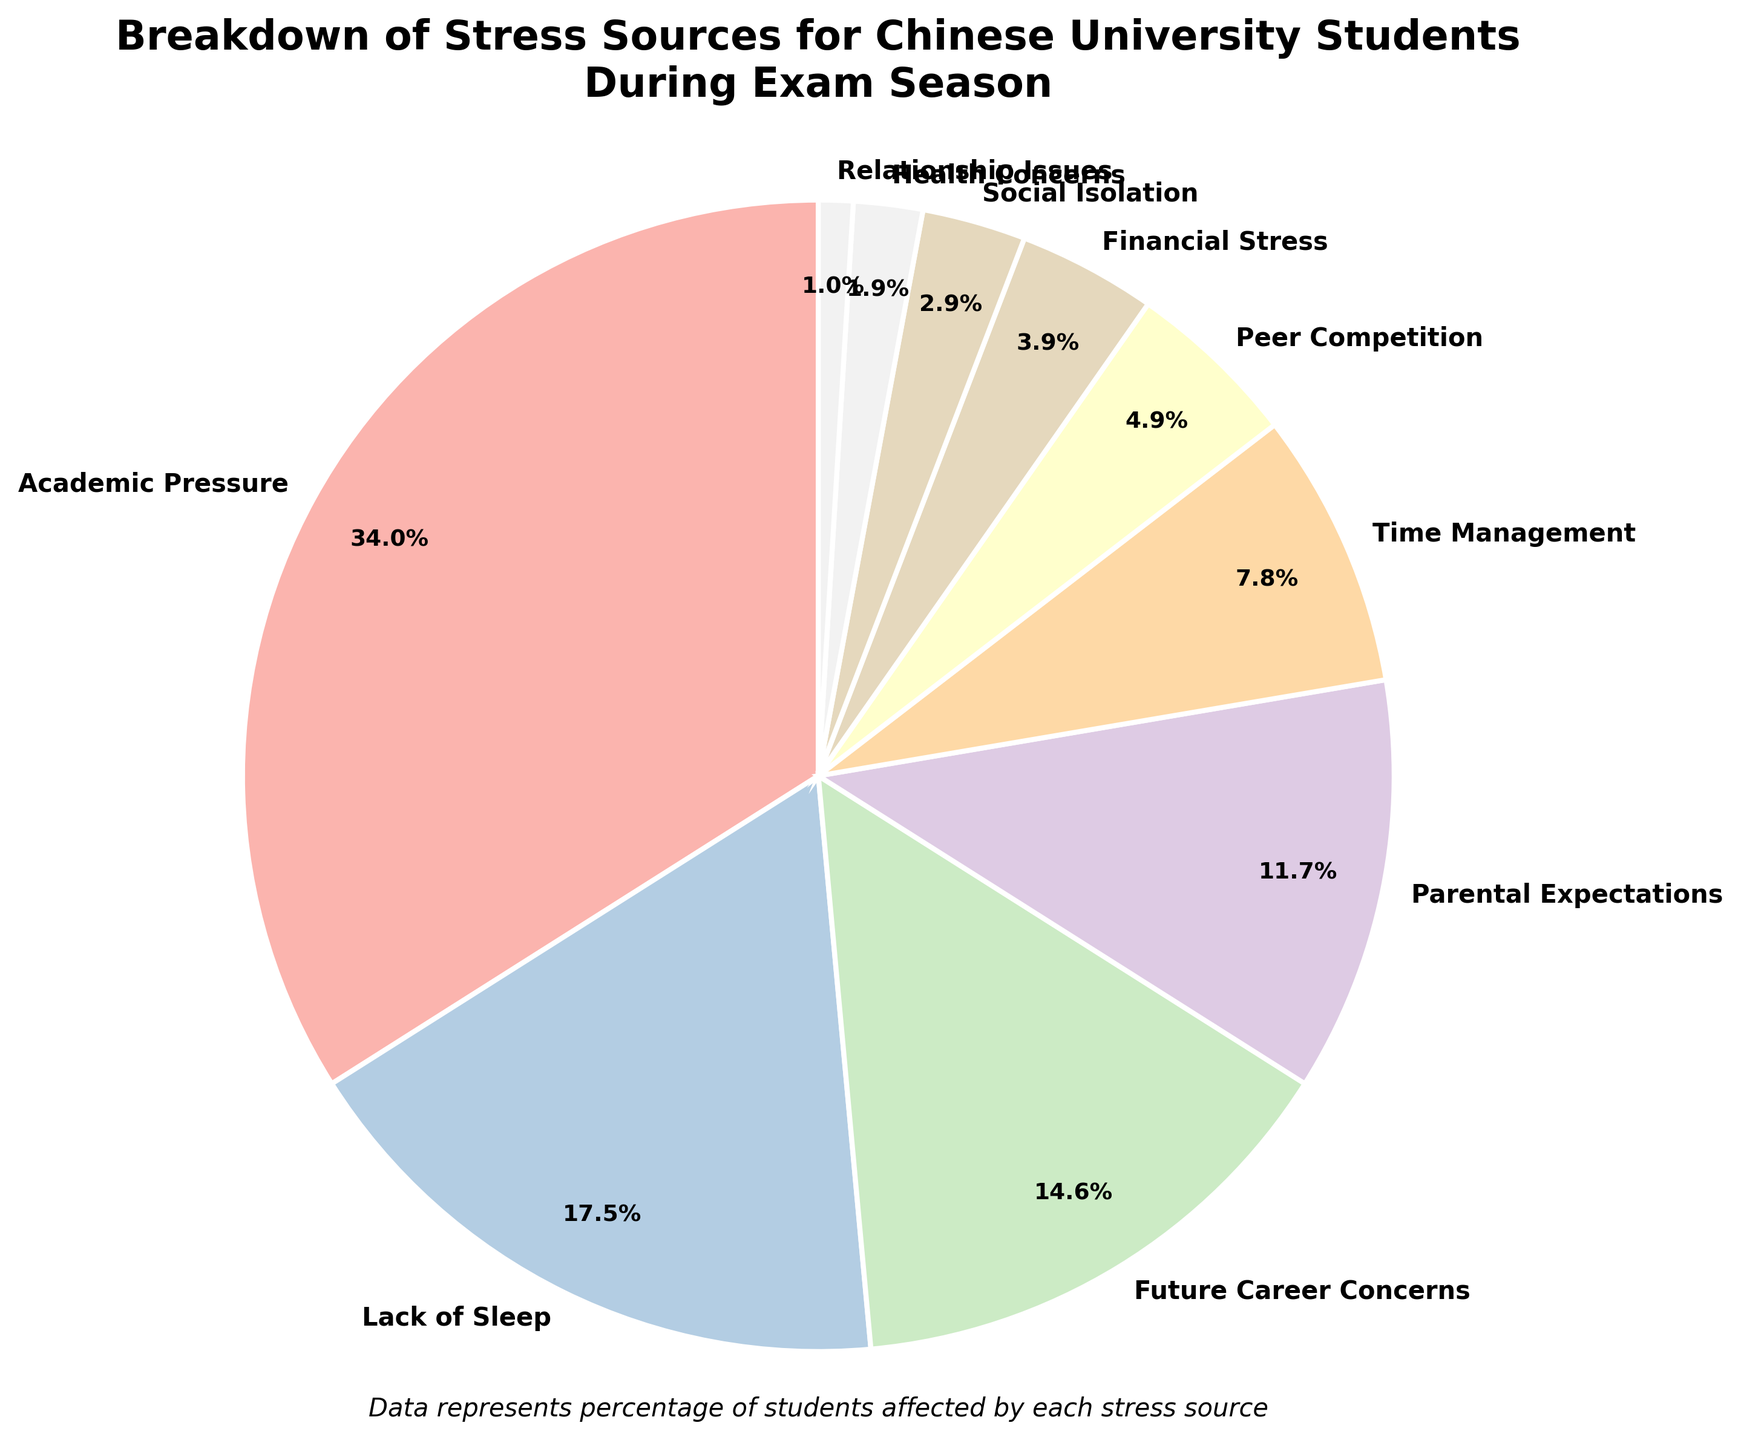What percentage of the stress sources is related to academic pressures? Locate the section labeled "Academic Pressure" in the pie chart. The percentage is specified directly next to the label.
Answer: 35% How much more percentage does lack of sleep contribute compared to financial stress? Find the sections labeled "Lack of Sleep" and "Financial Stress". Subtract the percentage of financial stress (4%) from the lack of sleep (18%). 18% - 4% = 14%.
Answer: 14% What is the combined percentage of students experiencing stress due to parental expectations and time management? Locate the sections labeled "Parental Expectations" and "Time Management". Sum their percentages: 12% + 8% = 20%.
Answer: 20% Which stress sources have a percentage less than peer competition? Find the section labeled "Peer Competition" and note its percentage (5%). List the sections with percentages less than 5%: Financial Stress (4%), Social Isolation (3%), Health Concerns (2%), and Relationship Issues (1%).
Answer: Financial Stress, Social Isolation, Health Concerns, Relationship Issues What is the difference in percentage between academic pressure and future career concerns? Locate the sections labeled "Academic Pressure" (35%) and "Future Career Concerns" (15%). Subtract the percentage for future career concerns from academic pressure: 35% - 15% = 20%.
Answer: 20% What percentage of stress sources contribute to social isolation and health concerns combined? Locate the sections labeled "Social Isolation" and "Health Concerns". Sum their percentages: 3% + 2% = 5%.
Answer: 5% Which stress source has the smallest share and what is its percentage? Identify the section with the smallest percentage. The "Relationship Issues" section has the smallest share with 1%.
Answer: Relationship Issues, 1% How does parental expectations' percentage compare to future career concerns' percentage? Locate the sections labeled "Parental Expectations" (12%) and "Future Career Concerns" (15%). Compare the values to determine which is larger and by how much: 15% - 12% = 3%.
Answer: Future Career Concerns is 3% higher What are the top three stress sources and their combined percentage? Identify the three sections with the highest percentages: Academic Pressure (35%), Lack of Sleep (18%), and Future Career Concerns (15%). Sum their percentages: 35% + 18% + 15% = 68%.
Answer: Academic Pressure, Lack of Sleep, Future Career Concerns; 68% How many stress sources contribute a percentage that is less than 10%? List the sections with percentages below 10%: Time Management (8%), Peer Competition (5%), Financial Stress (4%), Social Isolation (3%), Health Concerns (2%), and Relationship Issues (1%). Count them: 6 stress sources.
Answer: 6 